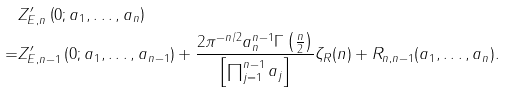Convert formula to latex. <formula><loc_0><loc_0><loc_500><loc_500>& Z _ { E , n } ^ { \prime } \left ( 0 ; a _ { 1 } , \dots , a _ { n } \right ) \\ = & Z _ { E , n - 1 } ^ { \prime } \left ( 0 ; a _ { 1 } , \dots , a _ { n - 1 } \right ) + \frac { 2 \pi ^ { - n / 2 } a _ { n } ^ { n - 1 } \Gamma \left ( \frac { n } { 2 } \right ) } { \left [ \prod _ { j = 1 } ^ { n - 1 } a _ { j } \right ] } \zeta _ { R } ( n ) + R _ { n , n - 1 } ( a _ { 1 } , \dots , a _ { n } ) .</formula> 